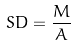Convert formula to latex. <formula><loc_0><loc_0><loc_500><loc_500>S D = \frac { M } { A }</formula> 